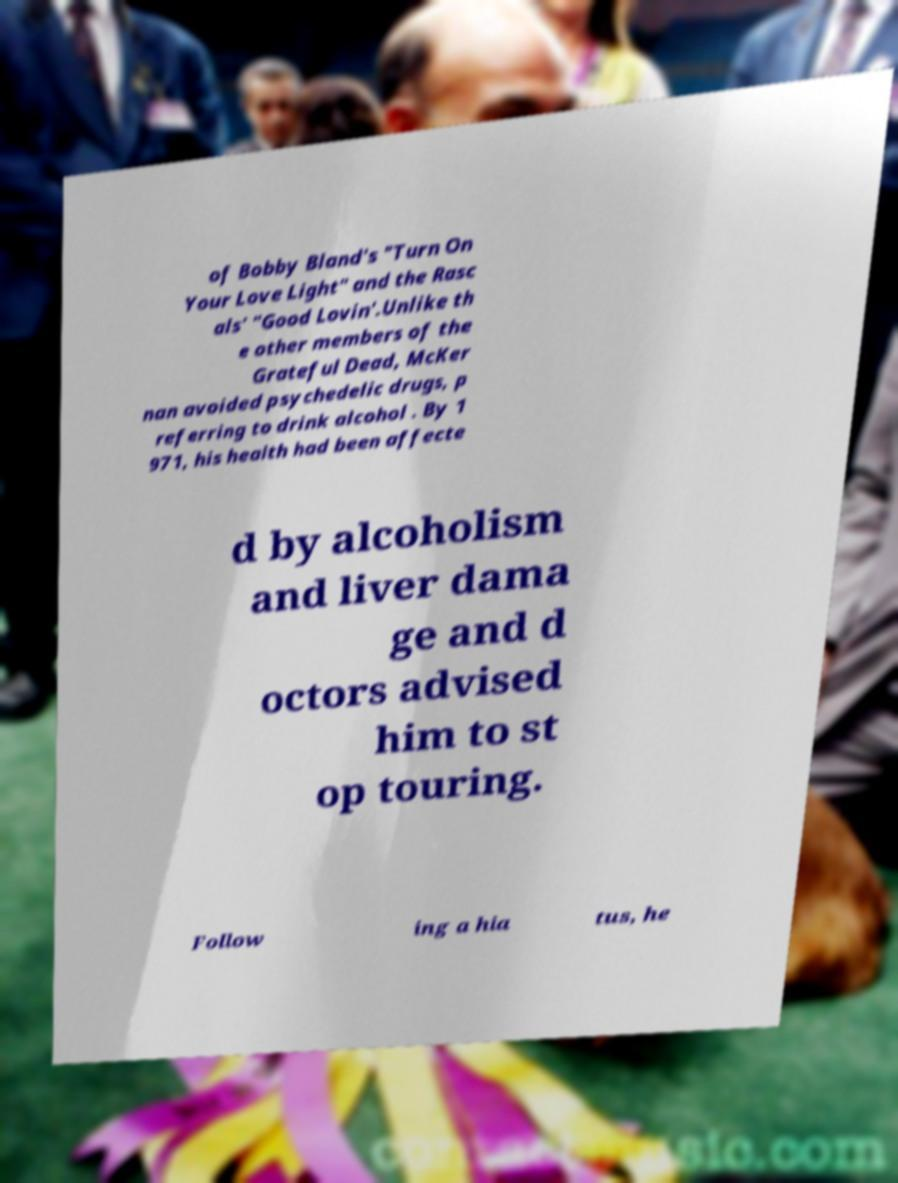What messages or text are displayed in this image? I need them in a readable, typed format. of Bobby Bland's "Turn On Your Love Light" and the Rasc als' "Good Lovin'.Unlike th e other members of the Grateful Dead, McKer nan avoided psychedelic drugs, p referring to drink alcohol . By 1 971, his health had been affecte d by alcoholism and liver dama ge and d octors advised him to st op touring. Follow ing a hia tus, he 